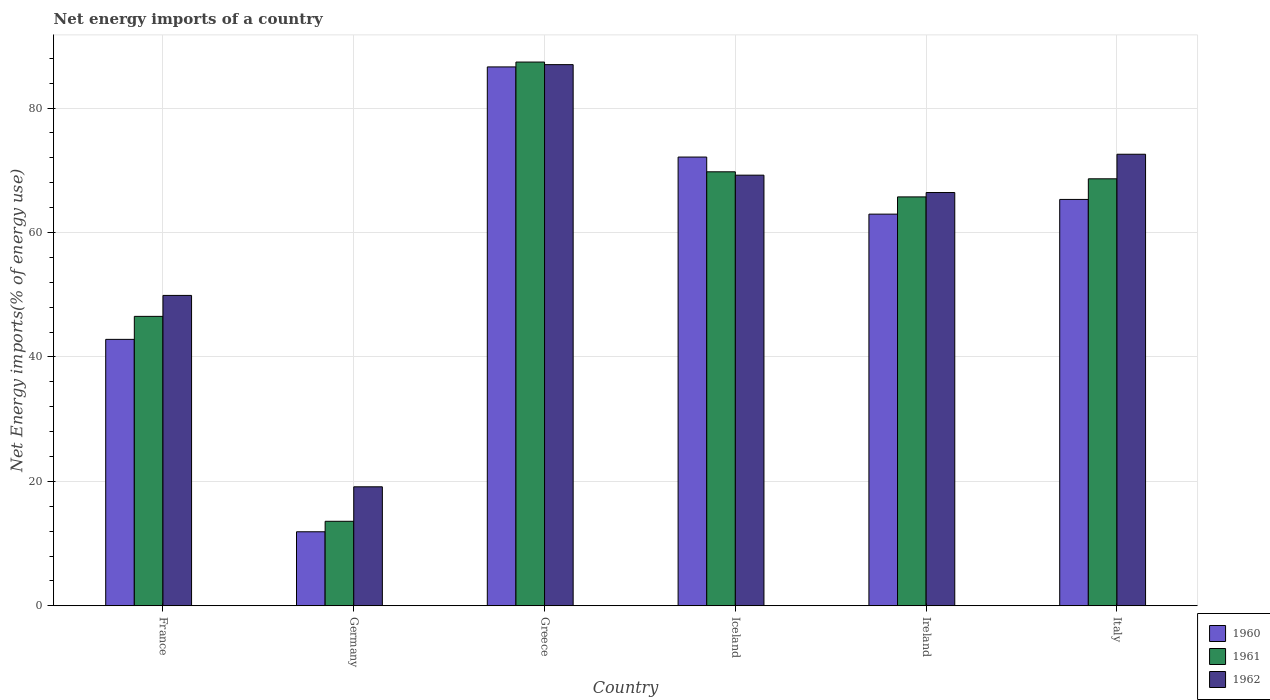How many different coloured bars are there?
Give a very brief answer. 3. How many groups of bars are there?
Offer a very short reply. 6. How many bars are there on the 6th tick from the left?
Your answer should be very brief. 3. How many bars are there on the 5th tick from the right?
Provide a succinct answer. 3. What is the net energy imports in 1961 in Ireland?
Offer a very short reply. 65.72. Across all countries, what is the maximum net energy imports in 1961?
Keep it short and to the point. 87.4. Across all countries, what is the minimum net energy imports in 1960?
Your answer should be compact. 11.9. What is the total net energy imports in 1962 in the graph?
Provide a succinct answer. 364.22. What is the difference between the net energy imports in 1960 in Iceland and that in Italy?
Keep it short and to the point. 6.81. What is the difference between the net energy imports in 1961 in Germany and the net energy imports in 1960 in Ireland?
Ensure brevity in your answer.  -49.37. What is the average net energy imports in 1962 per country?
Make the answer very short. 60.7. What is the difference between the net energy imports of/in 1960 and net energy imports of/in 1962 in Iceland?
Make the answer very short. 2.91. What is the ratio of the net energy imports in 1961 in France to that in Italy?
Your response must be concise. 0.68. Is the difference between the net energy imports in 1960 in France and Greece greater than the difference between the net energy imports in 1962 in France and Greece?
Give a very brief answer. No. What is the difference between the highest and the second highest net energy imports in 1962?
Ensure brevity in your answer.  3.36. What is the difference between the highest and the lowest net energy imports in 1962?
Offer a very short reply. 67.86. Is the sum of the net energy imports in 1962 in France and Greece greater than the maximum net energy imports in 1961 across all countries?
Your answer should be compact. Yes. Is it the case that in every country, the sum of the net energy imports in 1962 and net energy imports in 1960 is greater than the net energy imports in 1961?
Give a very brief answer. Yes. Are the values on the major ticks of Y-axis written in scientific E-notation?
Ensure brevity in your answer.  No. Does the graph contain any zero values?
Give a very brief answer. No. Where does the legend appear in the graph?
Provide a succinct answer. Bottom right. What is the title of the graph?
Ensure brevity in your answer.  Net energy imports of a country. Does "2008" appear as one of the legend labels in the graph?
Offer a very short reply. No. What is the label or title of the Y-axis?
Provide a short and direct response. Net Energy imports(% of energy use). What is the Net Energy imports(% of energy use) in 1960 in France?
Give a very brief answer. 42.82. What is the Net Energy imports(% of energy use) of 1961 in France?
Your answer should be compact. 46.52. What is the Net Energy imports(% of energy use) in 1962 in France?
Provide a succinct answer. 49.89. What is the Net Energy imports(% of energy use) of 1960 in Germany?
Your response must be concise. 11.9. What is the Net Energy imports(% of energy use) in 1961 in Germany?
Your response must be concise. 13.58. What is the Net Energy imports(% of energy use) in 1962 in Germany?
Ensure brevity in your answer.  19.13. What is the Net Energy imports(% of energy use) of 1960 in Greece?
Provide a succinct answer. 86.62. What is the Net Energy imports(% of energy use) of 1961 in Greece?
Provide a short and direct response. 87.4. What is the Net Energy imports(% of energy use) in 1962 in Greece?
Offer a terse response. 86.98. What is the Net Energy imports(% of energy use) in 1960 in Iceland?
Your response must be concise. 72.13. What is the Net Energy imports(% of energy use) of 1961 in Iceland?
Provide a short and direct response. 69.76. What is the Net Energy imports(% of energy use) in 1962 in Iceland?
Your response must be concise. 69.22. What is the Net Energy imports(% of energy use) of 1960 in Ireland?
Your answer should be compact. 62.95. What is the Net Energy imports(% of energy use) in 1961 in Ireland?
Offer a terse response. 65.72. What is the Net Energy imports(% of energy use) of 1962 in Ireland?
Your response must be concise. 66.43. What is the Net Energy imports(% of energy use) of 1960 in Italy?
Your response must be concise. 65.32. What is the Net Energy imports(% of energy use) of 1961 in Italy?
Keep it short and to the point. 68.63. What is the Net Energy imports(% of energy use) in 1962 in Italy?
Your response must be concise. 72.58. Across all countries, what is the maximum Net Energy imports(% of energy use) of 1960?
Your answer should be very brief. 86.62. Across all countries, what is the maximum Net Energy imports(% of energy use) in 1961?
Ensure brevity in your answer.  87.4. Across all countries, what is the maximum Net Energy imports(% of energy use) of 1962?
Ensure brevity in your answer.  86.98. Across all countries, what is the minimum Net Energy imports(% of energy use) in 1960?
Provide a short and direct response. 11.9. Across all countries, what is the minimum Net Energy imports(% of energy use) in 1961?
Your response must be concise. 13.58. Across all countries, what is the minimum Net Energy imports(% of energy use) in 1962?
Ensure brevity in your answer.  19.13. What is the total Net Energy imports(% of energy use) in 1960 in the graph?
Your answer should be very brief. 341.73. What is the total Net Energy imports(% of energy use) in 1961 in the graph?
Ensure brevity in your answer.  351.61. What is the total Net Energy imports(% of energy use) in 1962 in the graph?
Give a very brief answer. 364.22. What is the difference between the Net Energy imports(% of energy use) of 1960 in France and that in Germany?
Keep it short and to the point. 30.93. What is the difference between the Net Energy imports(% of energy use) of 1961 in France and that in Germany?
Provide a short and direct response. 32.94. What is the difference between the Net Energy imports(% of energy use) of 1962 in France and that in Germany?
Your response must be concise. 30.76. What is the difference between the Net Energy imports(% of energy use) in 1960 in France and that in Greece?
Your answer should be compact. -43.79. What is the difference between the Net Energy imports(% of energy use) of 1961 in France and that in Greece?
Offer a very short reply. -40.87. What is the difference between the Net Energy imports(% of energy use) of 1962 in France and that in Greece?
Offer a terse response. -37.09. What is the difference between the Net Energy imports(% of energy use) of 1960 in France and that in Iceland?
Your response must be concise. -29.3. What is the difference between the Net Energy imports(% of energy use) of 1961 in France and that in Iceland?
Make the answer very short. -23.24. What is the difference between the Net Energy imports(% of energy use) in 1962 in France and that in Iceland?
Offer a terse response. -19.33. What is the difference between the Net Energy imports(% of energy use) in 1960 in France and that in Ireland?
Give a very brief answer. -20.13. What is the difference between the Net Energy imports(% of energy use) in 1961 in France and that in Ireland?
Your answer should be compact. -19.2. What is the difference between the Net Energy imports(% of energy use) of 1962 in France and that in Ireland?
Give a very brief answer. -16.54. What is the difference between the Net Energy imports(% of energy use) of 1960 in France and that in Italy?
Offer a terse response. -22.49. What is the difference between the Net Energy imports(% of energy use) in 1961 in France and that in Italy?
Give a very brief answer. -22.11. What is the difference between the Net Energy imports(% of energy use) in 1962 in France and that in Italy?
Provide a short and direct response. -22.69. What is the difference between the Net Energy imports(% of energy use) in 1960 in Germany and that in Greece?
Your response must be concise. -74.72. What is the difference between the Net Energy imports(% of energy use) of 1961 in Germany and that in Greece?
Your response must be concise. -73.81. What is the difference between the Net Energy imports(% of energy use) of 1962 in Germany and that in Greece?
Ensure brevity in your answer.  -67.86. What is the difference between the Net Energy imports(% of energy use) of 1960 in Germany and that in Iceland?
Provide a short and direct response. -60.23. What is the difference between the Net Energy imports(% of energy use) of 1961 in Germany and that in Iceland?
Make the answer very short. -56.17. What is the difference between the Net Energy imports(% of energy use) in 1962 in Germany and that in Iceland?
Make the answer very short. -50.09. What is the difference between the Net Energy imports(% of energy use) in 1960 in Germany and that in Ireland?
Provide a succinct answer. -51.05. What is the difference between the Net Energy imports(% of energy use) in 1961 in Germany and that in Ireland?
Offer a terse response. -52.14. What is the difference between the Net Energy imports(% of energy use) of 1962 in Germany and that in Ireland?
Your answer should be very brief. -47.3. What is the difference between the Net Energy imports(% of energy use) in 1960 in Germany and that in Italy?
Offer a very short reply. -53.42. What is the difference between the Net Energy imports(% of energy use) in 1961 in Germany and that in Italy?
Offer a very short reply. -55.05. What is the difference between the Net Energy imports(% of energy use) in 1962 in Germany and that in Italy?
Your answer should be very brief. -53.45. What is the difference between the Net Energy imports(% of energy use) of 1960 in Greece and that in Iceland?
Your response must be concise. 14.49. What is the difference between the Net Energy imports(% of energy use) in 1961 in Greece and that in Iceland?
Make the answer very short. 17.64. What is the difference between the Net Energy imports(% of energy use) in 1962 in Greece and that in Iceland?
Your answer should be very brief. 17.77. What is the difference between the Net Energy imports(% of energy use) of 1960 in Greece and that in Ireland?
Your response must be concise. 23.66. What is the difference between the Net Energy imports(% of energy use) in 1961 in Greece and that in Ireland?
Keep it short and to the point. 21.67. What is the difference between the Net Energy imports(% of energy use) in 1962 in Greece and that in Ireland?
Ensure brevity in your answer.  20.56. What is the difference between the Net Energy imports(% of energy use) of 1960 in Greece and that in Italy?
Give a very brief answer. 21.3. What is the difference between the Net Energy imports(% of energy use) of 1961 in Greece and that in Italy?
Keep it short and to the point. 18.77. What is the difference between the Net Energy imports(% of energy use) in 1962 in Greece and that in Italy?
Offer a terse response. 14.4. What is the difference between the Net Energy imports(% of energy use) of 1960 in Iceland and that in Ireland?
Ensure brevity in your answer.  9.18. What is the difference between the Net Energy imports(% of energy use) of 1961 in Iceland and that in Ireland?
Your answer should be compact. 4.03. What is the difference between the Net Energy imports(% of energy use) of 1962 in Iceland and that in Ireland?
Offer a very short reply. 2.79. What is the difference between the Net Energy imports(% of energy use) of 1960 in Iceland and that in Italy?
Keep it short and to the point. 6.81. What is the difference between the Net Energy imports(% of energy use) in 1961 in Iceland and that in Italy?
Give a very brief answer. 1.13. What is the difference between the Net Energy imports(% of energy use) in 1962 in Iceland and that in Italy?
Give a very brief answer. -3.36. What is the difference between the Net Energy imports(% of energy use) in 1960 in Ireland and that in Italy?
Give a very brief answer. -2.36. What is the difference between the Net Energy imports(% of energy use) of 1961 in Ireland and that in Italy?
Give a very brief answer. -2.91. What is the difference between the Net Energy imports(% of energy use) of 1962 in Ireland and that in Italy?
Give a very brief answer. -6.15. What is the difference between the Net Energy imports(% of energy use) in 1960 in France and the Net Energy imports(% of energy use) in 1961 in Germany?
Ensure brevity in your answer.  29.24. What is the difference between the Net Energy imports(% of energy use) in 1960 in France and the Net Energy imports(% of energy use) in 1962 in Germany?
Your response must be concise. 23.7. What is the difference between the Net Energy imports(% of energy use) of 1961 in France and the Net Energy imports(% of energy use) of 1962 in Germany?
Your response must be concise. 27.39. What is the difference between the Net Energy imports(% of energy use) of 1960 in France and the Net Energy imports(% of energy use) of 1961 in Greece?
Provide a short and direct response. -44.57. What is the difference between the Net Energy imports(% of energy use) in 1960 in France and the Net Energy imports(% of energy use) in 1962 in Greece?
Your response must be concise. -44.16. What is the difference between the Net Energy imports(% of energy use) in 1961 in France and the Net Energy imports(% of energy use) in 1962 in Greece?
Ensure brevity in your answer.  -40.46. What is the difference between the Net Energy imports(% of energy use) of 1960 in France and the Net Energy imports(% of energy use) of 1961 in Iceland?
Keep it short and to the point. -26.93. What is the difference between the Net Energy imports(% of energy use) in 1960 in France and the Net Energy imports(% of energy use) in 1962 in Iceland?
Provide a succinct answer. -26.39. What is the difference between the Net Energy imports(% of energy use) in 1961 in France and the Net Energy imports(% of energy use) in 1962 in Iceland?
Provide a succinct answer. -22.7. What is the difference between the Net Energy imports(% of energy use) in 1960 in France and the Net Energy imports(% of energy use) in 1961 in Ireland?
Your answer should be compact. -22.9. What is the difference between the Net Energy imports(% of energy use) in 1960 in France and the Net Energy imports(% of energy use) in 1962 in Ireland?
Make the answer very short. -23.6. What is the difference between the Net Energy imports(% of energy use) in 1961 in France and the Net Energy imports(% of energy use) in 1962 in Ireland?
Your answer should be compact. -19.91. What is the difference between the Net Energy imports(% of energy use) of 1960 in France and the Net Energy imports(% of energy use) of 1961 in Italy?
Ensure brevity in your answer.  -25.81. What is the difference between the Net Energy imports(% of energy use) in 1960 in France and the Net Energy imports(% of energy use) in 1962 in Italy?
Provide a succinct answer. -29.76. What is the difference between the Net Energy imports(% of energy use) of 1961 in France and the Net Energy imports(% of energy use) of 1962 in Italy?
Provide a succinct answer. -26.06. What is the difference between the Net Energy imports(% of energy use) in 1960 in Germany and the Net Energy imports(% of energy use) in 1961 in Greece?
Make the answer very short. -75.5. What is the difference between the Net Energy imports(% of energy use) of 1960 in Germany and the Net Energy imports(% of energy use) of 1962 in Greece?
Provide a succinct answer. -75.08. What is the difference between the Net Energy imports(% of energy use) of 1961 in Germany and the Net Energy imports(% of energy use) of 1962 in Greece?
Keep it short and to the point. -73.4. What is the difference between the Net Energy imports(% of energy use) in 1960 in Germany and the Net Energy imports(% of energy use) in 1961 in Iceland?
Keep it short and to the point. -57.86. What is the difference between the Net Energy imports(% of energy use) in 1960 in Germany and the Net Energy imports(% of energy use) in 1962 in Iceland?
Offer a terse response. -57.32. What is the difference between the Net Energy imports(% of energy use) in 1961 in Germany and the Net Energy imports(% of energy use) in 1962 in Iceland?
Ensure brevity in your answer.  -55.63. What is the difference between the Net Energy imports(% of energy use) of 1960 in Germany and the Net Energy imports(% of energy use) of 1961 in Ireland?
Your answer should be compact. -53.82. What is the difference between the Net Energy imports(% of energy use) in 1960 in Germany and the Net Energy imports(% of energy use) in 1962 in Ireland?
Make the answer very short. -54.53. What is the difference between the Net Energy imports(% of energy use) of 1961 in Germany and the Net Energy imports(% of energy use) of 1962 in Ireland?
Your answer should be compact. -52.84. What is the difference between the Net Energy imports(% of energy use) of 1960 in Germany and the Net Energy imports(% of energy use) of 1961 in Italy?
Ensure brevity in your answer.  -56.73. What is the difference between the Net Energy imports(% of energy use) of 1960 in Germany and the Net Energy imports(% of energy use) of 1962 in Italy?
Keep it short and to the point. -60.68. What is the difference between the Net Energy imports(% of energy use) of 1961 in Germany and the Net Energy imports(% of energy use) of 1962 in Italy?
Give a very brief answer. -59. What is the difference between the Net Energy imports(% of energy use) in 1960 in Greece and the Net Energy imports(% of energy use) in 1961 in Iceland?
Give a very brief answer. 16.86. What is the difference between the Net Energy imports(% of energy use) in 1960 in Greece and the Net Energy imports(% of energy use) in 1962 in Iceland?
Ensure brevity in your answer.  17.4. What is the difference between the Net Energy imports(% of energy use) of 1961 in Greece and the Net Energy imports(% of energy use) of 1962 in Iceland?
Your response must be concise. 18.18. What is the difference between the Net Energy imports(% of energy use) of 1960 in Greece and the Net Energy imports(% of energy use) of 1961 in Ireland?
Keep it short and to the point. 20.89. What is the difference between the Net Energy imports(% of energy use) in 1960 in Greece and the Net Energy imports(% of energy use) in 1962 in Ireland?
Offer a very short reply. 20.19. What is the difference between the Net Energy imports(% of energy use) in 1961 in Greece and the Net Energy imports(% of energy use) in 1962 in Ireland?
Your answer should be compact. 20.97. What is the difference between the Net Energy imports(% of energy use) in 1960 in Greece and the Net Energy imports(% of energy use) in 1961 in Italy?
Your answer should be compact. 17.99. What is the difference between the Net Energy imports(% of energy use) of 1960 in Greece and the Net Energy imports(% of energy use) of 1962 in Italy?
Give a very brief answer. 14.04. What is the difference between the Net Energy imports(% of energy use) of 1961 in Greece and the Net Energy imports(% of energy use) of 1962 in Italy?
Make the answer very short. 14.82. What is the difference between the Net Energy imports(% of energy use) of 1960 in Iceland and the Net Energy imports(% of energy use) of 1961 in Ireland?
Offer a very short reply. 6.41. What is the difference between the Net Energy imports(% of energy use) in 1960 in Iceland and the Net Energy imports(% of energy use) in 1962 in Ireland?
Ensure brevity in your answer.  5.7. What is the difference between the Net Energy imports(% of energy use) of 1961 in Iceland and the Net Energy imports(% of energy use) of 1962 in Ireland?
Provide a short and direct response. 3.33. What is the difference between the Net Energy imports(% of energy use) in 1960 in Iceland and the Net Energy imports(% of energy use) in 1961 in Italy?
Provide a succinct answer. 3.5. What is the difference between the Net Energy imports(% of energy use) in 1960 in Iceland and the Net Energy imports(% of energy use) in 1962 in Italy?
Give a very brief answer. -0.45. What is the difference between the Net Energy imports(% of energy use) in 1961 in Iceland and the Net Energy imports(% of energy use) in 1962 in Italy?
Your answer should be very brief. -2.82. What is the difference between the Net Energy imports(% of energy use) in 1960 in Ireland and the Net Energy imports(% of energy use) in 1961 in Italy?
Provide a succinct answer. -5.68. What is the difference between the Net Energy imports(% of energy use) of 1960 in Ireland and the Net Energy imports(% of energy use) of 1962 in Italy?
Make the answer very short. -9.63. What is the difference between the Net Energy imports(% of energy use) of 1961 in Ireland and the Net Energy imports(% of energy use) of 1962 in Italy?
Your response must be concise. -6.86. What is the average Net Energy imports(% of energy use) of 1960 per country?
Keep it short and to the point. 56.96. What is the average Net Energy imports(% of energy use) of 1961 per country?
Ensure brevity in your answer.  58.6. What is the average Net Energy imports(% of energy use) of 1962 per country?
Provide a succinct answer. 60.7. What is the difference between the Net Energy imports(% of energy use) in 1960 and Net Energy imports(% of energy use) in 1961 in France?
Provide a succinct answer. -3.7. What is the difference between the Net Energy imports(% of energy use) of 1960 and Net Energy imports(% of energy use) of 1962 in France?
Your response must be concise. -7.06. What is the difference between the Net Energy imports(% of energy use) in 1961 and Net Energy imports(% of energy use) in 1962 in France?
Provide a short and direct response. -3.37. What is the difference between the Net Energy imports(% of energy use) of 1960 and Net Energy imports(% of energy use) of 1961 in Germany?
Offer a very short reply. -1.68. What is the difference between the Net Energy imports(% of energy use) of 1960 and Net Energy imports(% of energy use) of 1962 in Germany?
Provide a short and direct response. -7.23. What is the difference between the Net Energy imports(% of energy use) in 1961 and Net Energy imports(% of energy use) in 1962 in Germany?
Provide a succinct answer. -5.54. What is the difference between the Net Energy imports(% of energy use) in 1960 and Net Energy imports(% of energy use) in 1961 in Greece?
Ensure brevity in your answer.  -0.78. What is the difference between the Net Energy imports(% of energy use) of 1960 and Net Energy imports(% of energy use) of 1962 in Greece?
Make the answer very short. -0.37. What is the difference between the Net Energy imports(% of energy use) of 1961 and Net Energy imports(% of energy use) of 1962 in Greece?
Your answer should be very brief. 0.41. What is the difference between the Net Energy imports(% of energy use) in 1960 and Net Energy imports(% of energy use) in 1961 in Iceland?
Your answer should be compact. 2.37. What is the difference between the Net Energy imports(% of energy use) of 1960 and Net Energy imports(% of energy use) of 1962 in Iceland?
Keep it short and to the point. 2.91. What is the difference between the Net Energy imports(% of energy use) in 1961 and Net Energy imports(% of energy use) in 1962 in Iceland?
Your response must be concise. 0.54. What is the difference between the Net Energy imports(% of energy use) in 1960 and Net Energy imports(% of energy use) in 1961 in Ireland?
Give a very brief answer. -2.77. What is the difference between the Net Energy imports(% of energy use) of 1960 and Net Energy imports(% of energy use) of 1962 in Ireland?
Keep it short and to the point. -3.47. What is the difference between the Net Energy imports(% of energy use) of 1961 and Net Energy imports(% of energy use) of 1962 in Ireland?
Make the answer very short. -0.7. What is the difference between the Net Energy imports(% of energy use) of 1960 and Net Energy imports(% of energy use) of 1961 in Italy?
Ensure brevity in your answer.  -3.31. What is the difference between the Net Energy imports(% of energy use) in 1960 and Net Energy imports(% of energy use) in 1962 in Italy?
Offer a very short reply. -7.26. What is the difference between the Net Energy imports(% of energy use) of 1961 and Net Energy imports(% of energy use) of 1962 in Italy?
Ensure brevity in your answer.  -3.95. What is the ratio of the Net Energy imports(% of energy use) in 1960 in France to that in Germany?
Offer a very short reply. 3.6. What is the ratio of the Net Energy imports(% of energy use) of 1961 in France to that in Germany?
Your answer should be very brief. 3.43. What is the ratio of the Net Energy imports(% of energy use) of 1962 in France to that in Germany?
Your answer should be very brief. 2.61. What is the ratio of the Net Energy imports(% of energy use) of 1960 in France to that in Greece?
Your answer should be very brief. 0.49. What is the ratio of the Net Energy imports(% of energy use) of 1961 in France to that in Greece?
Ensure brevity in your answer.  0.53. What is the ratio of the Net Energy imports(% of energy use) in 1962 in France to that in Greece?
Keep it short and to the point. 0.57. What is the ratio of the Net Energy imports(% of energy use) in 1960 in France to that in Iceland?
Provide a short and direct response. 0.59. What is the ratio of the Net Energy imports(% of energy use) of 1961 in France to that in Iceland?
Make the answer very short. 0.67. What is the ratio of the Net Energy imports(% of energy use) of 1962 in France to that in Iceland?
Give a very brief answer. 0.72. What is the ratio of the Net Energy imports(% of energy use) of 1960 in France to that in Ireland?
Provide a short and direct response. 0.68. What is the ratio of the Net Energy imports(% of energy use) of 1961 in France to that in Ireland?
Your response must be concise. 0.71. What is the ratio of the Net Energy imports(% of energy use) in 1962 in France to that in Ireland?
Offer a terse response. 0.75. What is the ratio of the Net Energy imports(% of energy use) of 1960 in France to that in Italy?
Provide a short and direct response. 0.66. What is the ratio of the Net Energy imports(% of energy use) in 1961 in France to that in Italy?
Keep it short and to the point. 0.68. What is the ratio of the Net Energy imports(% of energy use) in 1962 in France to that in Italy?
Keep it short and to the point. 0.69. What is the ratio of the Net Energy imports(% of energy use) of 1960 in Germany to that in Greece?
Provide a succinct answer. 0.14. What is the ratio of the Net Energy imports(% of energy use) in 1961 in Germany to that in Greece?
Ensure brevity in your answer.  0.16. What is the ratio of the Net Energy imports(% of energy use) in 1962 in Germany to that in Greece?
Offer a terse response. 0.22. What is the ratio of the Net Energy imports(% of energy use) in 1960 in Germany to that in Iceland?
Offer a very short reply. 0.17. What is the ratio of the Net Energy imports(% of energy use) in 1961 in Germany to that in Iceland?
Make the answer very short. 0.19. What is the ratio of the Net Energy imports(% of energy use) of 1962 in Germany to that in Iceland?
Your answer should be compact. 0.28. What is the ratio of the Net Energy imports(% of energy use) of 1960 in Germany to that in Ireland?
Ensure brevity in your answer.  0.19. What is the ratio of the Net Energy imports(% of energy use) in 1961 in Germany to that in Ireland?
Provide a succinct answer. 0.21. What is the ratio of the Net Energy imports(% of energy use) in 1962 in Germany to that in Ireland?
Provide a succinct answer. 0.29. What is the ratio of the Net Energy imports(% of energy use) of 1960 in Germany to that in Italy?
Your response must be concise. 0.18. What is the ratio of the Net Energy imports(% of energy use) of 1961 in Germany to that in Italy?
Your answer should be compact. 0.2. What is the ratio of the Net Energy imports(% of energy use) of 1962 in Germany to that in Italy?
Your response must be concise. 0.26. What is the ratio of the Net Energy imports(% of energy use) in 1960 in Greece to that in Iceland?
Offer a terse response. 1.2. What is the ratio of the Net Energy imports(% of energy use) of 1961 in Greece to that in Iceland?
Your answer should be compact. 1.25. What is the ratio of the Net Energy imports(% of energy use) of 1962 in Greece to that in Iceland?
Offer a terse response. 1.26. What is the ratio of the Net Energy imports(% of energy use) in 1960 in Greece to that in Ireland?
Offer a terse response. 1.38. What is the ratio of the Net Energy imports(% of energy use) of 1961 in Greece to that in Ireland?
Provide a succinct answer. 1.33. What is the ratio of the Net Energy imports(% of energy use) in 1962 in Greece to that in Ireland?
Offer a very short reply. 1.31. What is the ratio of the Net Energy imports(% of energy use) in 1960 in Greece to that in Italy?
Ensure brevity in your answer.  1.33. What is the ratio of the Net Energy imports(% of energy use) in 1961 in Greece to that in Italy?
Ensure brevity in your answer.  1.27. What is the ratio of the Net Energy imports(% of energy use) in 1962 in Greece to that in Italy?
Your response must be concise. 1.2. What is the ratio of the Net Energy imports(% of energy use) of 1960 in Iceland to that in Ireland?
Keep it short and to the point. 1.15. What is the ratio of the Net Energy imports(% of energy use) of 1961 in Iceland to that in Ireland?
Offer a terse response. 1.06. What is the ratio of the Net Energy imports(% of energy use) in 1962 in Iceland to that in Ireland?
Ensure brevity in your answer.  1.04. What is the ratio of the Net Energy imports(% of energy use) in 1960 in Iceland to that in Italy?
Make the answer very short. 1.1. What is the ratio of the Net Energy imports(% of energy use) of 1961 in Iceland to that in Italy?
Your response must be concise. 1.02. What is the ratio of the Net Energy imports(% of energy use) in 1962 in Iceland to that in Italy?
Give a very brief answer. 0.95. What is the ratio of the Net Energy imports(% of energy use) in 1960 in Ireland to that in Italy?
Your answer should be very brief. 0.96. What is the ratio of the Net Energy imports(% of energy use) of 1961 in Ireland to that in Italy?
Your response must be concise. 0.96. What is the ratio of the Net Energy imports(% of energy use) of 1962 in Ireland to that in Italy?
Keep it short and to the point. 0.92. What is the difference between the highest and the second highest Net Energy imports(% of energy use) of 1960?
Offer a terse response. 14.49. What is the difference between the highest and the second highest Net Energy imports(% of energy use) in 1961?
Offer a terse response. 17.64. What is the difference between the highest and the second highest Net Energy imports(% of energy use) in 1962?
Offer a terse response. 14.4. What is the difference between the highest and the lowest Net Energy imports(% of energy use) in 1960?
Offer a very short reply. 74.72. What is the difference between the highest and the lowest Net Energy imports(% of energy use) of 1961?
Provide a short and direct response. 73.81. What is the difference between the highest and the lowest Net Energy imports(% of energy use) in 1962?
Make the answer very short. 67.86. 